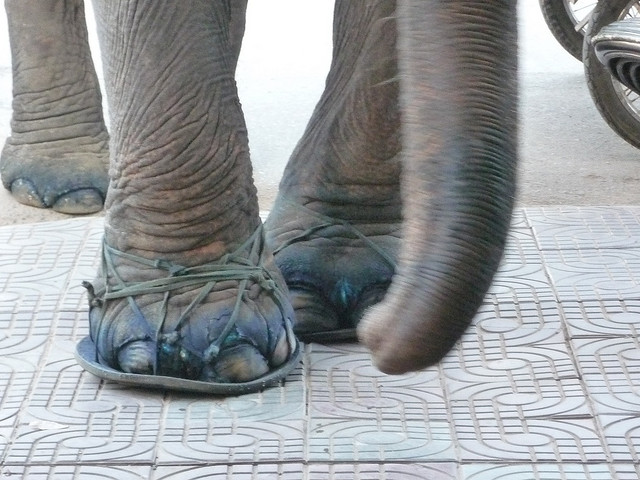<image>Why does the elephant have a shoe around two of its feet? It is not certain why the elephant has shoes around two of its feet. Suggestions include it may be for protection or due to injury. Why does the elephant have a shoe around two of its feet? I don't know why the elephant has a shoe around two of its feet. It could be for protecting its feet, injuries, or for better walking. 